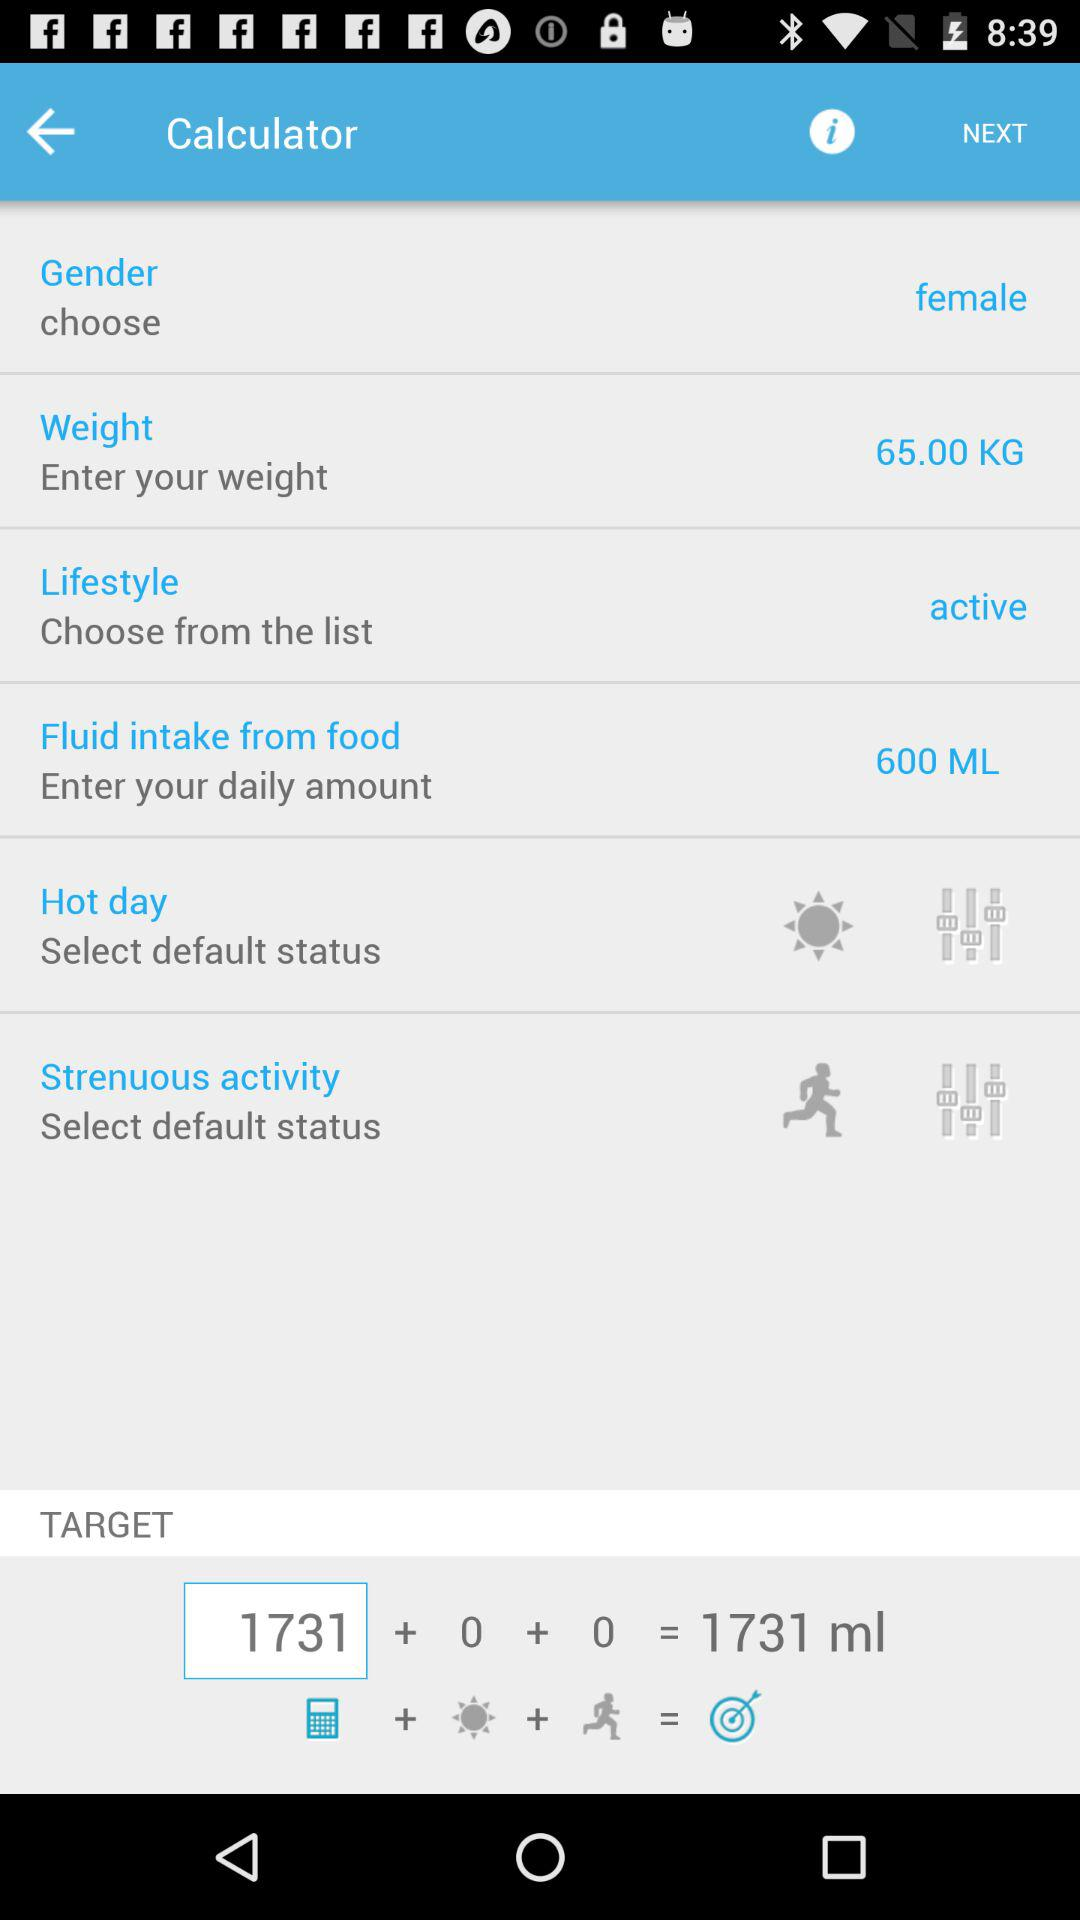Which gender is selected? The selected gender is female. 